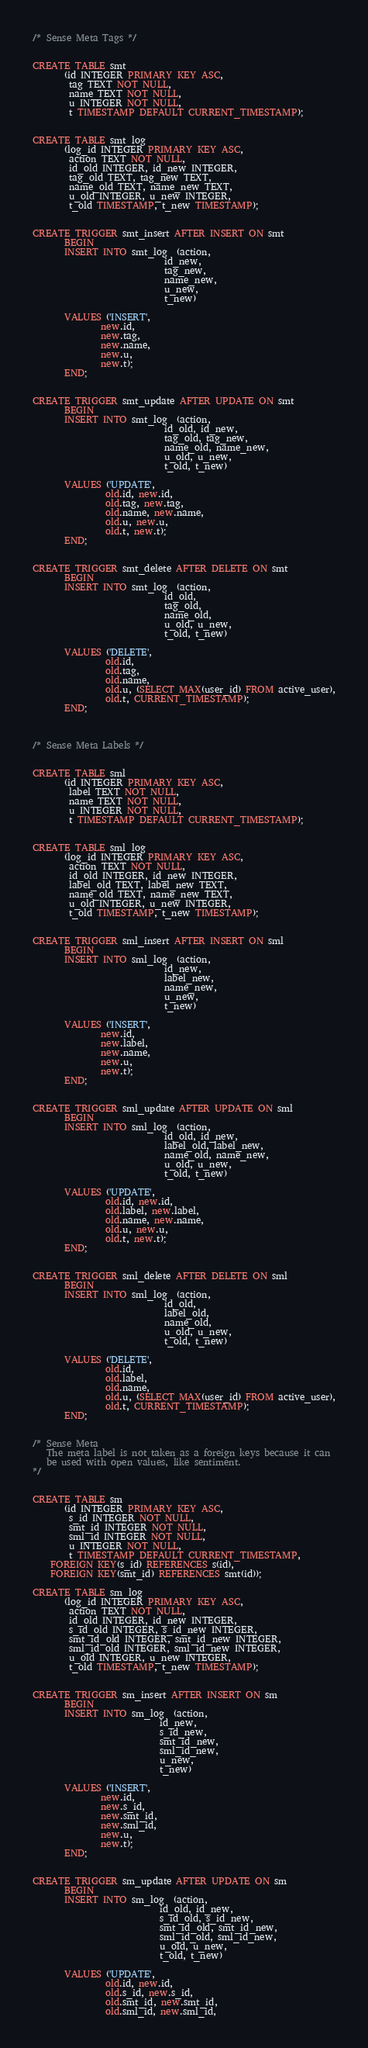<code> <loc_0><loc_0><loc_500><loc_500><_SQL_>


/* Sense Meta Tags */


CREATE TABLE smt
       (id INTEGER PRIMARY KEY ASC,
        tag TEXT NOT NULL,
        name TEXT NOT NULL,
        u INTEGER NOT NULL,
        t TIMESTAMP DEFAULT CURRENT_TIMESTAMP);


CREATE TABLE smt_log
       (log_id INTEGER PRIMARY KEY ASC,
        action TEXT NOT NULL,
        id_old INTEGER, id_new INTEGER,
        tag_old TEXT, tag_new TEXT,
        name_old TEXT, name_new TEXT,
        u_old INTEGER, u_new INTEGER,
        t_old TIMESTAMP, t_new TIMESTAMP);


CREATE TRIGGER smt_insert AFTER INSERT ON smt
       BEGIN
       INSERT INTO smt_log  (action,
                             id_new,
                             tag_new,
                             name_new,
                             u_new,
                             t_new)

       VALUES ('INSERT',
               new.id,
               new.tag,
               new.name,
               new.u,
               new.t);
       END;


CREATE TRIGGER smt_update AFTER UPDATE ON smt
       BEGIN
       INSERT INTO smt_log  (action,
                             id_old, id_new,
                             tag_old, tag_new,
                             name_old, name_new,
                             u_old, u_new,
                             t_old, t_new)

       VALUES ('UPDATE',
                old.id, new.id,
                old.tag, new.tag,
                old.name, new.name,
                old.u, new.u,
                old.t, new.t);
       END;


CREATE TRIGGER smt_delete AFTER DELETE ON smt
       BEGIN
       INSERT INTO smt_log  (action,
                             id_old,
                             tag_old,
                             name_old,
                             u_old, u_new,
                             t_old, t_new)

       VALUES ('DELETE',
                old.id,
                old.tag,
                old.name,
                old.u, (SELECT MAX(user_id) FROM active_user),
                old.t, CURRENT_TIMESTAMP);
       END;



/* Sense Meta Labels */


CREATE TABLE sml
       (id INTEGER PRIMARY KEY ASC,
        label TEXT NOT NULL,
        name TEXT NOT NULL,
        u INTEGER NOT NULL,
        t TIMESTAMP DEFAULT CURRENT_TIMESTAMP);


CREATE TABLE sml_log
       (log_id INTEGER PRIMARY KEY ASC,
        action TEXT NOT NULL,
        id_old INTEGER, id_new INTEGER,
        label_old TEXT, label_new TEXT,
        name_old TEXT, name_new TEXT,
        u_old INTEGER, u_new INTEGER,
        t_old TIMESTAMP, t_new TIMESTAMP);


CREATE TRIGGER sml_insert AFTER INSERT ON sml
       BEGIN
       INSERT INTO sml_log  (action,
                             id_new,
                             label_new,
                             name_new,
                             u_new,
                             t_new)

       VALUES ('INSERT',
               new.id,
               new.label,
               new.name,
               new.u,
               new.t);
       END;


CREATE TRIGGER sml_update AFTER UPDATE ON sml
       BEGIN
       INSERT INTO sml_log  (action,
                             id_old, id_new,
                             label_old, label_new,
                             name_old, name_new,
                             u_old, u_new,
                             t_old, t_new)

       VALUES ('UPDATE',
                old.id, new.id,
                old.label, new.label,
                old.name, new.name,
                old.u, new.u,
                old.t, new.t);
       END;


CREATE TRIGGER sml_delete AFTER DELETE ON sml
       BEGIN
       INSERT INTO sml_log  (action,
                             id_old,
                             label_old,
                             name_old,
                             u_old, u_new,
                             t_old, t_new)

       VALUES ('DELETE',
                old.id,
                old.label,
                old.name,
                old.u, (SELECT MAX(user_id) FROM active_user),
                old.t, CURRENT_TIMESTAMP);
       END;


/* Sense Meta
   The meta label is not taken as a foreign keys because it can
   be used with open values, like sentiment.
*/


CREATE TABLE sm
       (id INTEGER PRIMARY KEY ASC,
        s_id INTEGER NOT NULL,
        smt_id INTEGER NOT NULL,
        sml_id INTEGER NOT NULL,
        u INTEGER NOT NULL,
        t TIMESTAMP DEFAULT CURRENT_TIMESTAMP,
	FOREIGN KEY(s_id) REFERENCES s(id),
	FOREIGN KEY(smt_id) REFERENCES smt(id));

CREATE TABLE sm_log
       (log_id INTEGER PRIMARY KEY ASC,
        action TEXT NOT NULL,
        id_old INTEGER, id_new INTEGER,
        s_id_old INTEGER, s_id_new INTEGER,
        smt_id_old INTEGER, smt_id_new INTEGER,
        sml_id_old INTEGER, sml_id_new INTEGER,
        u_old INTEGER, u_new INTEGER,
        t_old TIMESTAMP, t_new TIMESTAMP);


CREATE TRIGGER sm_insert AFTER INSERT ON sm
       BEGIN
       INSERT INTO sm_log  (action,
                            id_new,
                            s_id_new,
                            smt_id_new,
                            sml_id_new,
                            u_new,
                            t_new)

       VALUES ('INSERT',
               new.id,
               new.s_id,
               new.smt_id,
               new.sml_id,
               new.u,
               new.t);
       END;


CREATE TRIGGER sm_update AFTER UPDATE ON sm
       BEGIN
       INSERT INTO sm_log  (action,
                            id_old, id_new,
                            s_id_old, s_id_new,
                            smt_id_old, smt_id_new,
                            sml_id_old, sml_id_new,
                            u_old, u_new,
                            t_old, t_new)

       VALUES ('UPDATE',
                old.id, new.id,
                old.s_id, new.s_id,
                old.smt_id, new.smt_id,
                old.sml_id, new.sml_id,</code> 